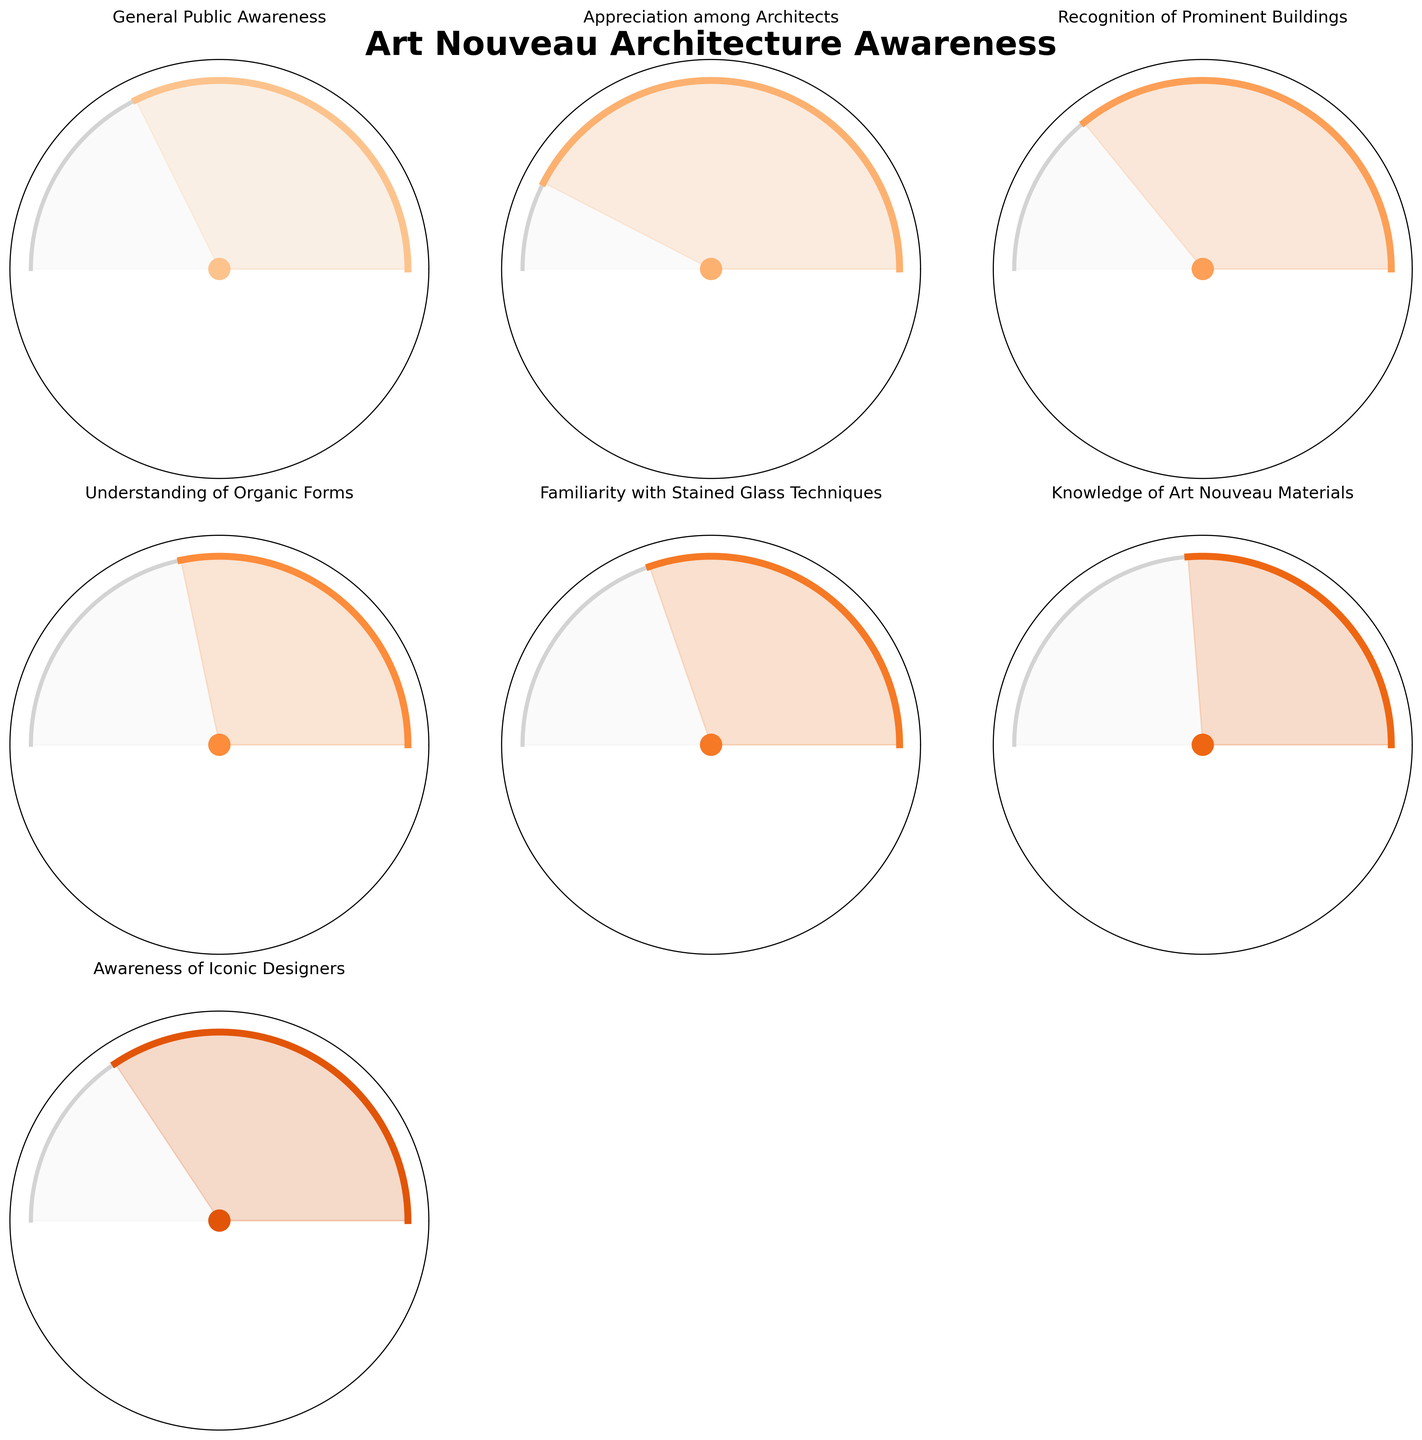What's the general public awareness of Art Nouveau architecture? Look at the gauge chart for 'General Public Awareness,' which shows its value.
Answer: 65% What category has the highest value? Compare the values of all categories and identify the highest value.
Answer: Appreciation among Architects Which is higher: Recognition of Prominent Buildings or Familiarity with Stained Glass Techniques? Compare the values of 'Recognition of Prominent Buildings' (72) and 'Familiarity with Stained Glass Techniques' (61).
Answer: Recognition of Prominent Buildings What's the average value of all categories? Sum all the values (65 + 85 + 72 + 58 + 61 + 53 + 69) and divide by the number of categories (7).
Answer: 66 What category has the lowest awareness value? Compare all the category values to find the smallest one.
Answer: Knowledge of Art Nouveau Materials What is the combined total of General Public Awareness and Awareness of Iconic Designers? Add the values for 'General Public Awareness' (65) and 'Awareness of Iconic Designers' (69).
Answer: 134 How much higher is the Appreciation among Architects compared to the Understanding of Organic Forms? Subtract the value of 'Understanding of Organic Forms' (58) from 'Appreciation among Architects' (85).
Answer: 27 What proportion of Understanding of Organic Forms is compared to the highest value category? Divide 'Understanding of Organic Forms' (58) by 'Appreciation among Architects' (85) and multiply by 100%.
Answer: 68.24% Which areas have awareness values above 70%? Identify the categories with values greater than 70: 'Appreciation among Architects' (85) and 'Recognition of Prominent Buildings' (72).
Answer: Appreciation among Architects, Recognition of Prominent Buildings 